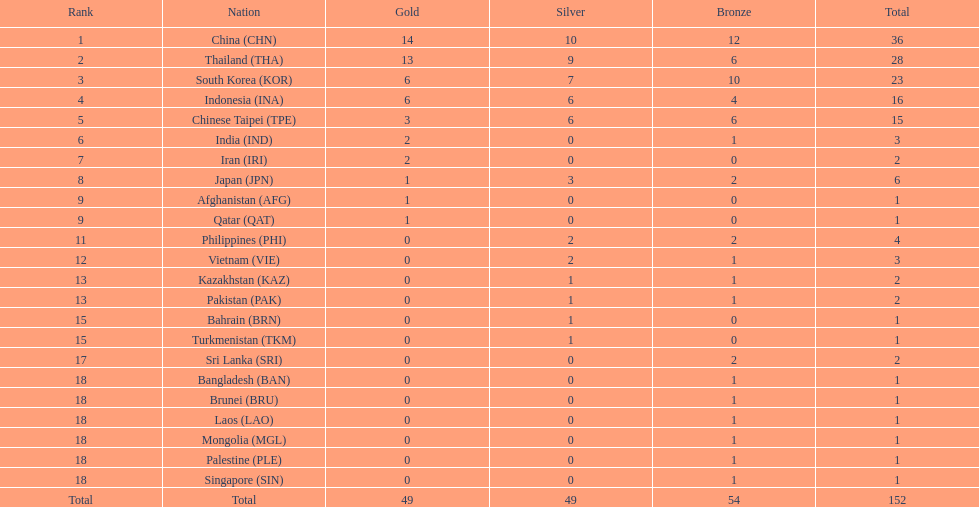How many nations secured more than 5 gold medals? 4. 